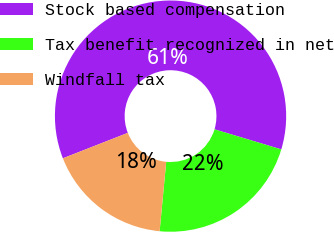Convert chart. <chart><loc_0><loc_0><loc_500><loc_500><pie_chart><fcel>Stock based compensation<fcel>Tax benefit recognized in net<fcel>Windfall tax<nl><fcel>60.59%<fcel>21.86%<fcel>17.55%<nl></chart> 